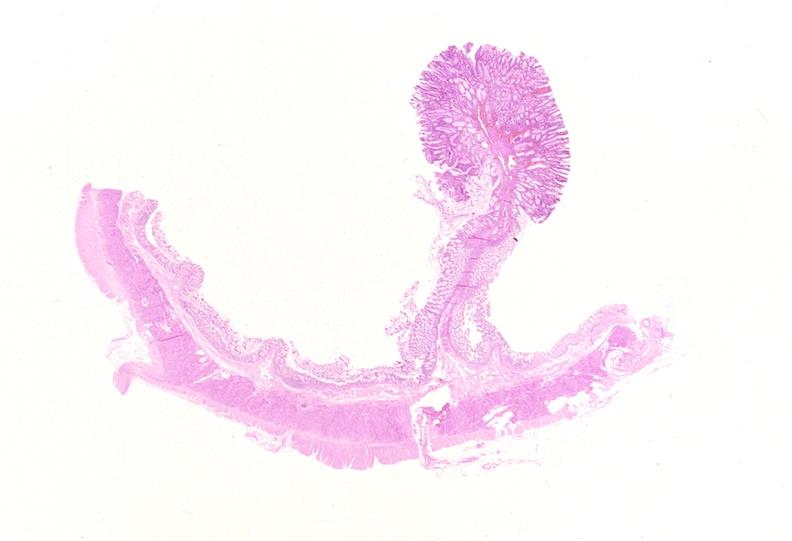where is this from?
Answer the question using a single word or phrase. Gastrointestinal system 